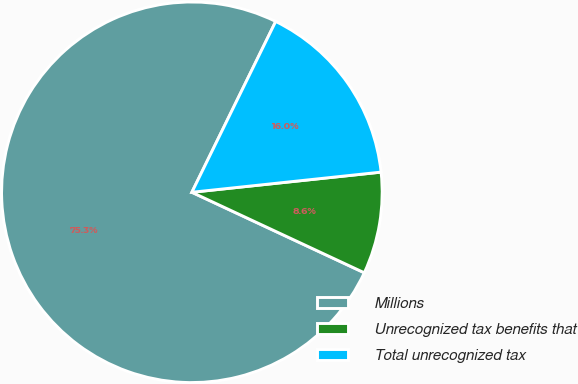Convert chart to OTSL. <chart><loc_0><loc_0><loc_500><loc_500><pie_chart><fcel>Millions<fcel>Unrecognized tax benefits that<fcel>Total unrecognized tax<nl><fcel>75.31%<fcel>8.64%<fcel>16.05%<nl></chart> 